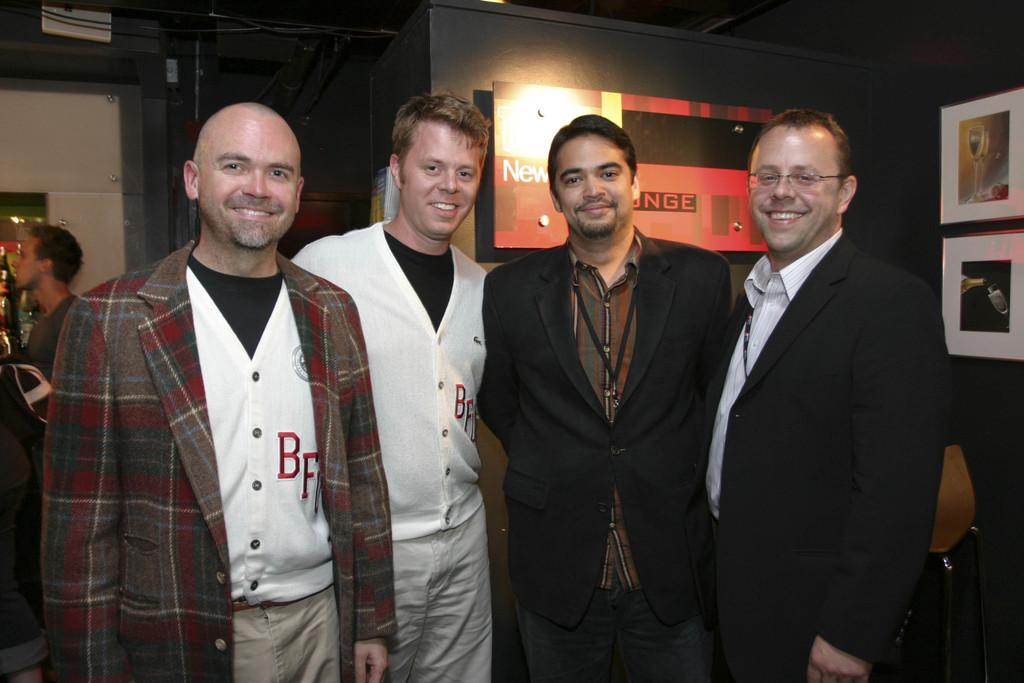How many people are present in the image? There are four persons standing in the image. Can you describe the background of the image? There are other objects visible in the background of the image, but specific details are not provided. What type of doctor is treating the carpenter in the image? There is no doctor or carpenter present in the image; it only features four persons standing. 